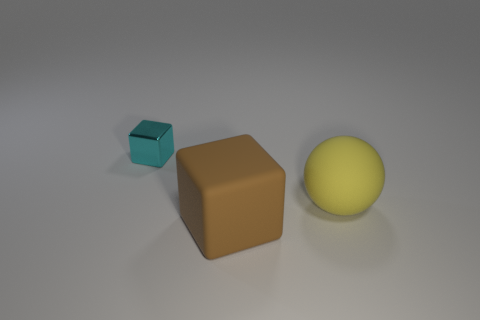Is the number of tiny cyan cubes greater than the number of small blue shiny cubes?
Offer a terse response. Yes. What is the material of the large yellow thing?
Your response must be concise. Rubber. How many other things are there of the same material as the small cyan object?
Give a very brief answer. 0. What number of big red shiny objects are there?
Provide a succinct answer. 0. What is the material of the cyan object that is the same shape as the brown matte thing?
Provide a succinct answer. Metal. Are the block that is in front of the small cyan thing and the big sphere made of the same material?
Provide a succinct answer. Yes. Are there more small blocks in front of the brown matte thing than tiny metal things that are left of the cyan thing?
Offer a terse response. No. The rubber ball is what size?
Offer a very short reply. Large. The big brown object that is made of the same material as the yellow thing is what shape?
Ensure brevity in your answer.  Cube. There is a object behind the large yellow rubber thing; does it have the same shape as the brown matte object?
Make the answer very short. Yes. 